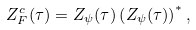Convert formula to latex. <formula><loc_0><loc_0><loc_500><loc_500>Z _ { F } ^ { c } ( \tau ) = Z _ { \psi } ( \tau ) \left ( Z _ { \psi } ( \tau ) \right ) ^ { * } ,</formula> 